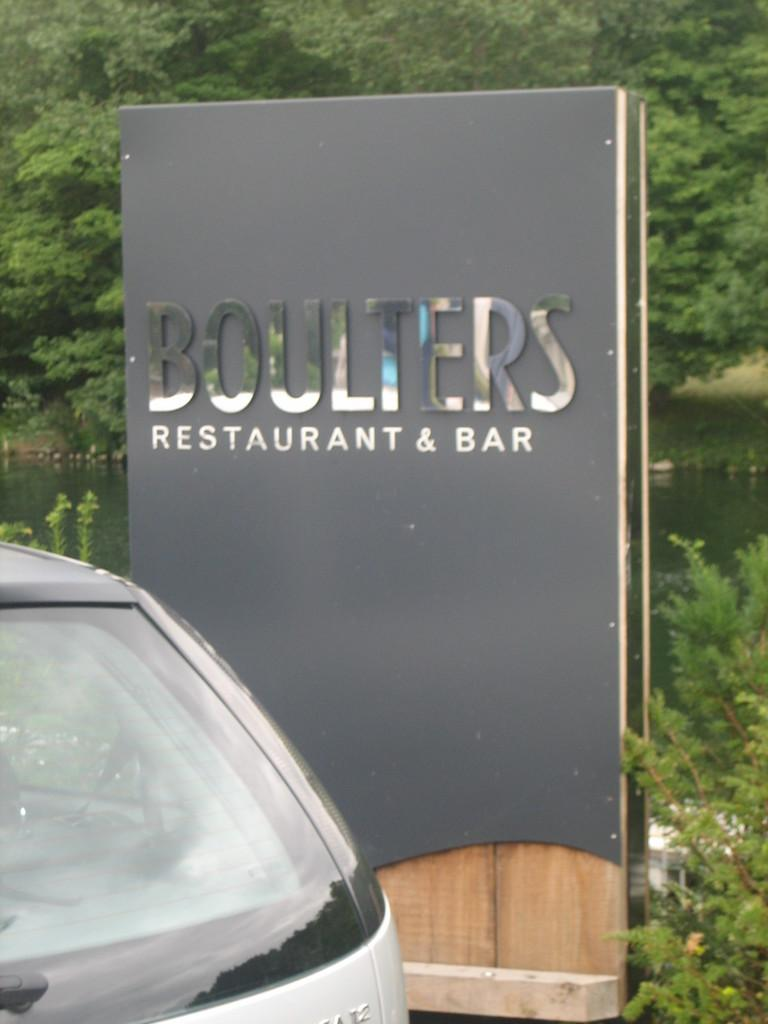What is located in the foreground of the picture? There are plants, a board, and a car in the foreground of the picture. What can be seen in the center of the picture? There is a water body in the center of the picture. What is visible in the background of the picture? There are trees in the background of the picture. What type of neck accessory is the car wearing in the image? There is no neck accessory present in the image, as the subject is a car. Can you tell me how many airplanes are flying over the water body in the image? There are no airplanes visible in the image; it only features a water body, plants, a board, a car, and trees. 